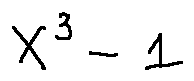Convert formula to latex. <formula><loc_0><loc_0><loc_500><loc_500>X ^ { 3 } - 1</formula> 